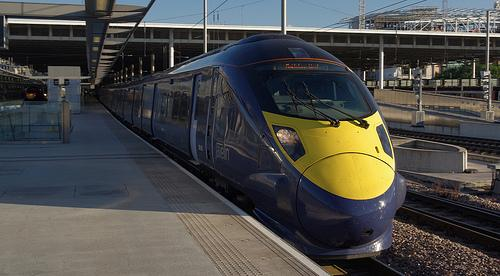Is the image quality adequate and clear for identifying objects present? Yes, the image quality is adequate and clear for identifying objects. Describe two features at the train platform. An empty train platform with a grey walkway and an overhead awning. Count the number of sets of black windshield wipers on the front of the train. There are two sets of black windshield wipers on the front of the train. What sentiment can be associated with the image of the train station? An atmosphere of anticipation and readiness can be associated with the image. Enumerate three visible components on the front of the train. Headlight, windshield wipers, and a large glass windshield are visible on the train's front. Mention a distinct color of the train's door and describe its position. There is a lighter blue colored door on the side of the train. What type of train is shown in the image and where is it located? A bullet train with a blue and yellow color scheme is located at a train station. How many illuminated headlights are present on the train? One round illuminated headlight is present on the train. What type of walkway is situated alongside the train? A large grey walkway is situated alongside the train. In terms of object interaction, what is immediately next to the train? Brown train tracks are immediately next to the train. How many windshield wipers are there on the bullet train? There are two windshield wipers. Identify the main objects in the image. Bullet train, empty train platform, windshield wipers, train tracks, overhead awning, headlight, door, cement pillar, background structure, blue sky, metal structures, and gray concrete barrier. Is there a group of people waiting on the empty train platform? The platform is described as 'empty', which implies that there are no people present. This instruction implies that there are people. Describe any anomalies or inconsistencies in the image. There are no significant anomalies or inconsistencies. What type of construction is happening in the background? A structure is being built in the background. Find and extract any text present in the image. There is no text present in the image. What is the quality of the image? The image is of high quality and detailed. What type of train is the most prominent in the image? A bullet train. List the different colors in the train. Blue, yellow, and lighter blue. How would you describe the appearance of the train platform? The train platform is empty and has a large grey walkway area. Determine which parts of the image belong to the bullet train and which parts belong to the platform. Bullet train: X:96 Y:30 Width:311 Height:311; Platform: X:0 Y:98 Width:316 Height:316. Which objects are mentioned in this text: "a lighter blue colored door on the side of the train"? A lighter blue colored door and the side of the train. How would you describe the sky in the image? Clear and blue. How would you describe the surface of the ground in the image? Gray concrete ground surface and gray gravel. Describe the emotions conveyed by the image. Neutral, calming, and orderly. Are the windshield wipers on the bullet train purple? The windshield wipers are described as black, so this instruction is providing a wrong color for the windshield wipers. What is the color of the nose of the train? Yellow. Is the train at the platform red and green? The train is described to be blue and yellow, so this instruction provides misleading colors for the train. Is there a bicycle parked near the cement pillar? No, it's not mentioned in the image. Does the train have square headlights? The headlights are described as round and illuminated, so this instruction is providing a misleading shape for the headlights. What object is interacting with the train tracks? A bullet train is interacting with the train tracks. What are the dimensions of the overhead awning of the train platform? X:75 Y:0 Width:54 Height:54. How many red tail lights are there in the far back? Two red tail lights. What color are the windshield wipers on the bullet train? The windshield wipers are black. 